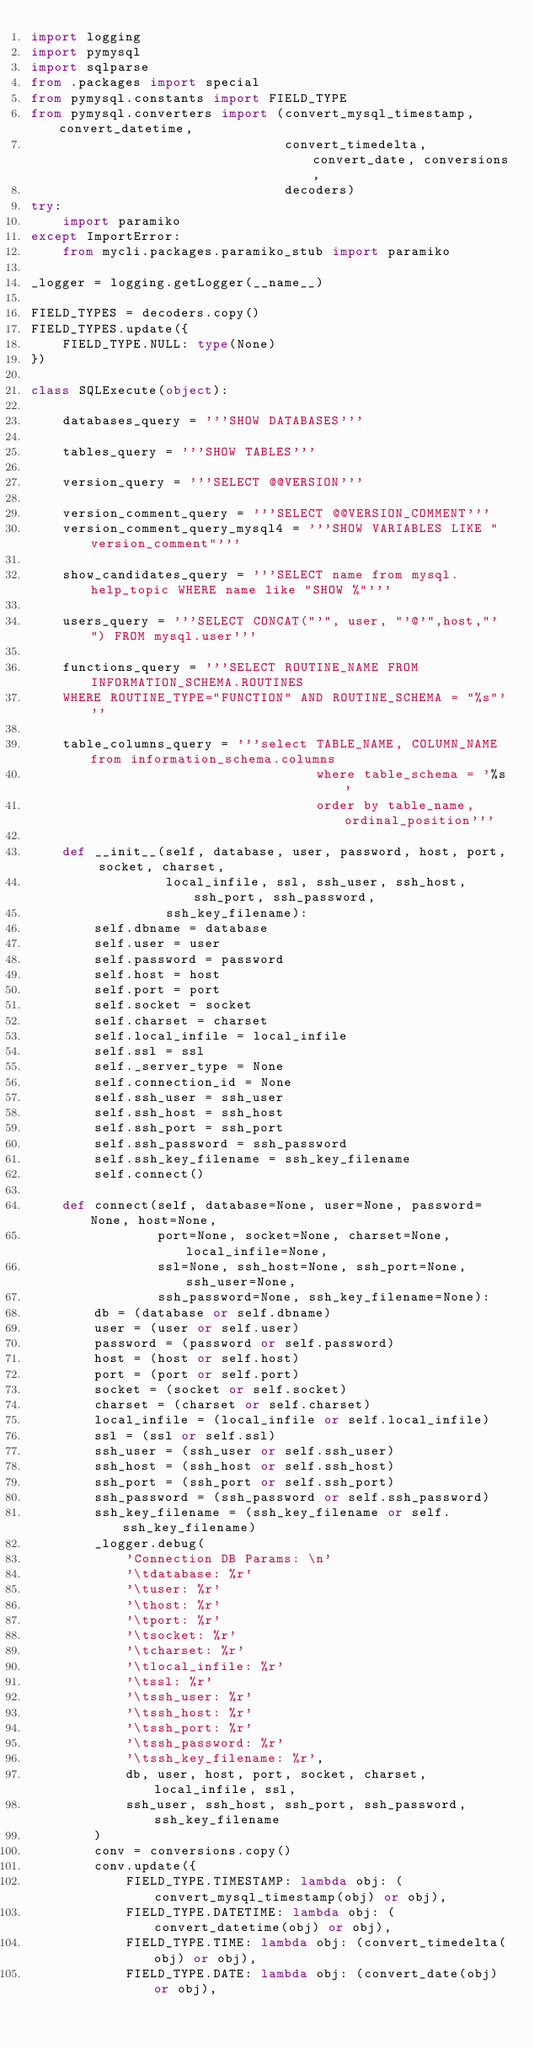<code> <loc_0><loc_0><loc_500><loc_500><_Python_>import logging
import pymysql
import sqlparse
from .packages import special
from pymysql.constants import FIELD_TYPE
from pymysql.converters import (convert_mysql_timestamp, convert_datetime,
                                convert_timedelta, convert_date, conversions,
                                decoders)
try:
    import paramiko
except ImportError:
    from mycli.packages.paramiko_stub import paramiko

_logger = logging.getLogger(__name__)

FIELD_TYPES = decoders.copy()
FIELD_TYPES.update({
    FIELD_TYPE.NULL: type(None)
})

class SQLExecute(object):

    databases_query = '''SHOW DATABASES'''

    tables_query = '''SHOW TABLES'''

    version_query = '''SELECT @@VERSION'''

    version_comment_query = '''SELECT @@VERSION_COMMENT'''
    version_comment_query_mysql4 = '''SHOW VARIABLES LIKE "version_comment"'''

    show_candidates_query = '''SELECT name from mysql.help_topic WHERE name like "SHOW %"'''

    users_query = '''SELECT CONCAT("'", user, "'@'",host,"'") FROM mysql.user'''

    functions_query = '''SELECT ROUTINE_NAME FROM INFORMATION_SCHEMA.ROUTINES
    WHERE ROUTINE_TYPE="FUNCTION" AND ROUTINE_SCHEMA = "%s"'''

    table_columns_query = '''select TABLE_NAME, COLUMN_NAME from information_schema.columns
                                    where table_schema = '%s'
                                    order by table_name,ordinal_position'''

    def __init__(self, database, user, password, host, port, socket, charset,
                 local_infile, ssl, ssh_user, ssh_host, ssh_port, ssh_password,
                 ssh_key_filename):
        self.dbname = database
        self.user = user
        self.password = password
        self.host = host
        self.port = port
        self.socket = socket
        self.charset = charset
        self.local_infile = local_infile
        self.ssl = ssl
        self._server_type = None
        self.connection_id = None
        self.ssh_user = ssh_user
        self.ssh_host = ssh_host
        self.ssh_port = ssh_port
        self.ssh_password = ssh_password
        self.ssh_key_filename = ssh_key_filename
        self.connect()

    def connect(self, database=None, user=None, password=None, host=None,
                port=None, socket=None, charset=None, local_infile=None,
                ssl=None, ssh_host=None, ssh_port=None, ssh_user=None,
                ssh_password=None, ssh_key_filename=None):
        db = (database or self.dbname)
        user = (user or self.user)
        password = (password or self.password)
        host = (host or self.host)
        port = (port or self.port)
        socket = (socket or self.socket)
        charset = (charset or self.charset)
        local_infile = (local_infile or self.local_infile)
        ssl = (ssl or self.ssl)
        ssh_user = (ssh_user or self.ssh_user)
        ssh_host = (ssh_host or self.ssh_host)
        ssh_port = (ssh_port or self.ssh_port)
        ssh_password = (ssh_password or self.ssh_password)
        ssh_key_filename = (ssh_key_filename or self.ssh_key_filename)
        _logger.debug(
            'Connection DB Params: \n'
            '\tdatabase: %r'
            '\tuser: %r'
            '\thost: %r'
            '\tport: %r'
            '\tsocket: %r'
            '\tcharset: %r'
            '\tlocal_infile: %r'
            '\tssl: %r'
            '\tssh_user: %r'
            '\tssh_host: %r'
            '\tssh_port: %r'
            '\tssh_password: %r'
            '\tssh_key_filename: %r',
            db, user, host, port, socket, charset, local_infile, ssl,
            ssh_user, ssh_host, ssh_port, ssh_password, ssh_key_filename
        )
        conv = conversions.copy()
        conv.update({
            FIELD_TYPE.TIMESTAMP: lambda obj: (convert_mysql_timestamp(obj) or obj),
            FIELD_TYPE.DATETIME: lambda obj: (convert_datetime(obj) or obj),
            FIELD_TYPE.TIME: lambda obj: (convert_timedelta(obj) or obj),
            FIELD_TYPE.DATE: lambda obj: (convert_date(obj) or obj),</code> 